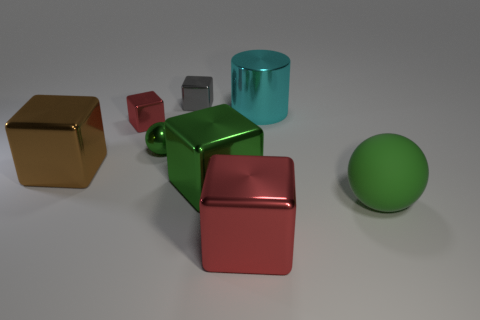Are there any other things that are the same shape as the big cyan shiny object?
Provide a short and direct response. No. How many other objects are the same material as the small gray cube?
Provide a short and direct response. 6. How many large objects are the same shape as the small gray thing?
Offer a terse response. 3. What color is the large block that is right of the small red metal block and behind the large green matte object?
Make the answer very short. Green. How many green matte balls are there?
Keep it short and to the point. 1. Is the gray cube the same size as the rubber thing?
Your answer should be very brief. No. Are there any small things of the same color as the large rubber ball?
Your answer should be compact. Yes. There is a big metal object that is behind the brown metallic thing; is its shape the same as the big green metallic thing?
Keep it short and to the point. No. How many brown cubes are the same size as the brown thing?
Provide a short and direct response. 0. What number of green rubber spheres are behind the red object that is behind the brown shiny object?
Ensure brevity in your answer.  0. 